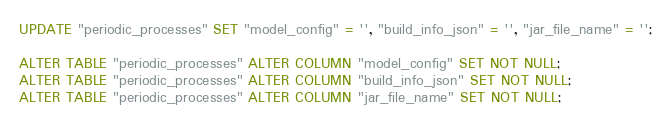Convert code to text. <code><loc_0><loc_0><loc_500><loc_500><_SQL_>UPDATE "periodic_processes" SET "model_config" = '', "build_info_json" = '', "jar_file_name" = '';

ALTER TABLE "periodic_processes" ALTER COLUMN "model_config" SET NOT NULL;
ALTER TABLE "periodic_processes" ALTER COLUMN "build_info_json" SET NOT NULL;
ALTER TABLE "periodic_processes" ALTER COLUMN "jar_file_name" SET NOT NULL;
</code> 